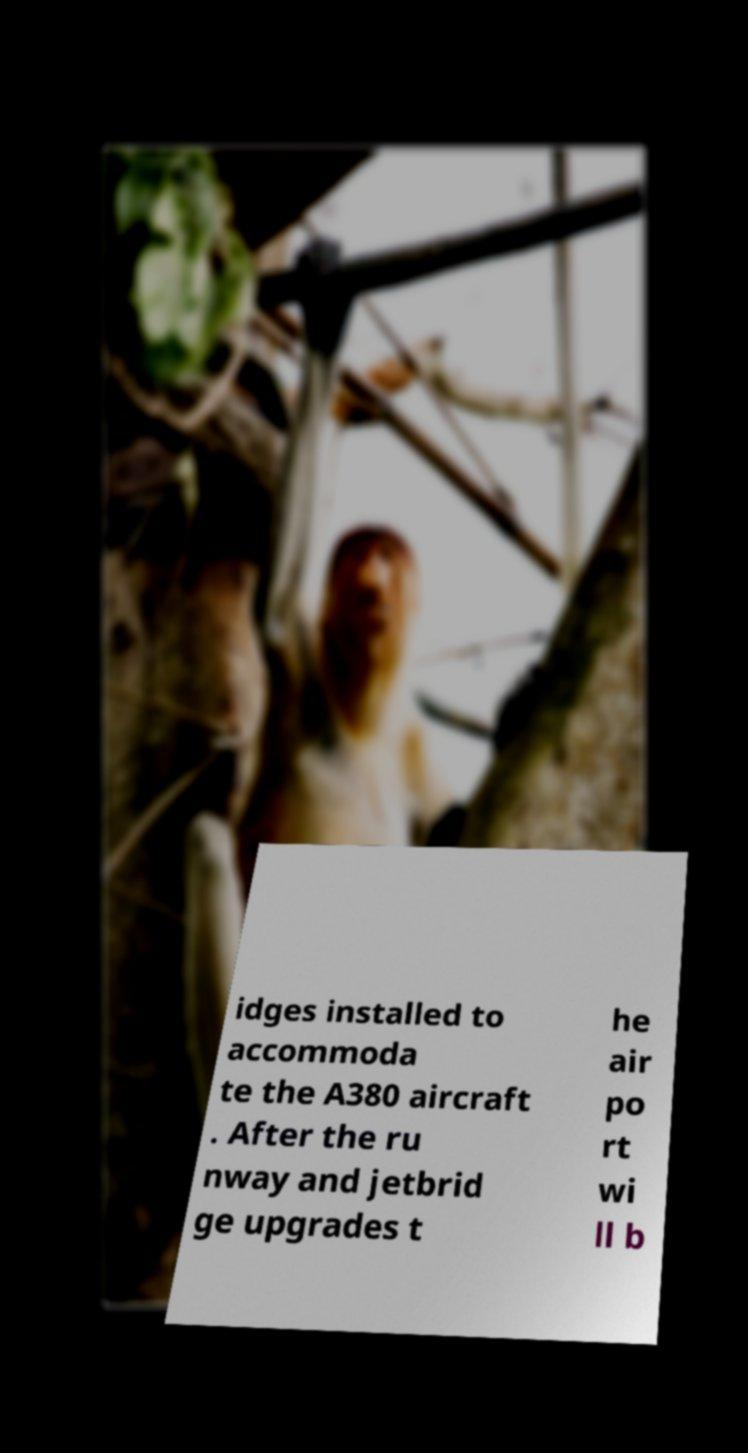Can you accurately transcribe the text from the provided image for me? idges installed to accommoda te the A380 aircraft . After the ru nway and jetbrid ge upgrades t he air po rt wi ll b 